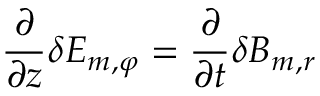Convert formula to latex. <formula><loc_0><loc_0><loc_500><loc_500>\frac { \partial } { \partial z } \delta E _ { m , \varphi } = \frac { \partial } { \partial t } \delta B _ { m , r }</formula> 